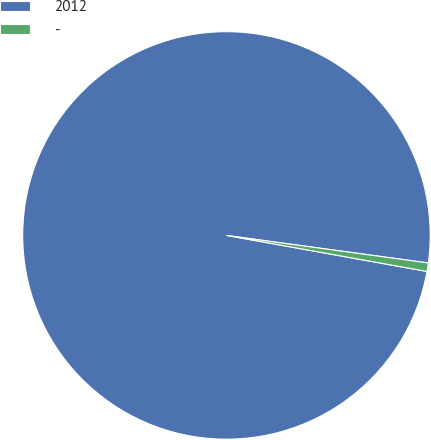Convert chart to OTSL. <chart><loc_0><loc_0><loc_500><loc_500><pie_chart><fcel>2012<fcel>-<nl><fcel>99.33%<fcel>0.67%<nl></chart> 